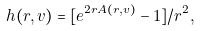Convert formula to latex. <formula><loc_0><loc_0><loc_500><loc_500>h ( r , v ) = [ e ^ { 2 r A ( r , v ) } - 1 ] / r ^ { 2 } ,</formula> 